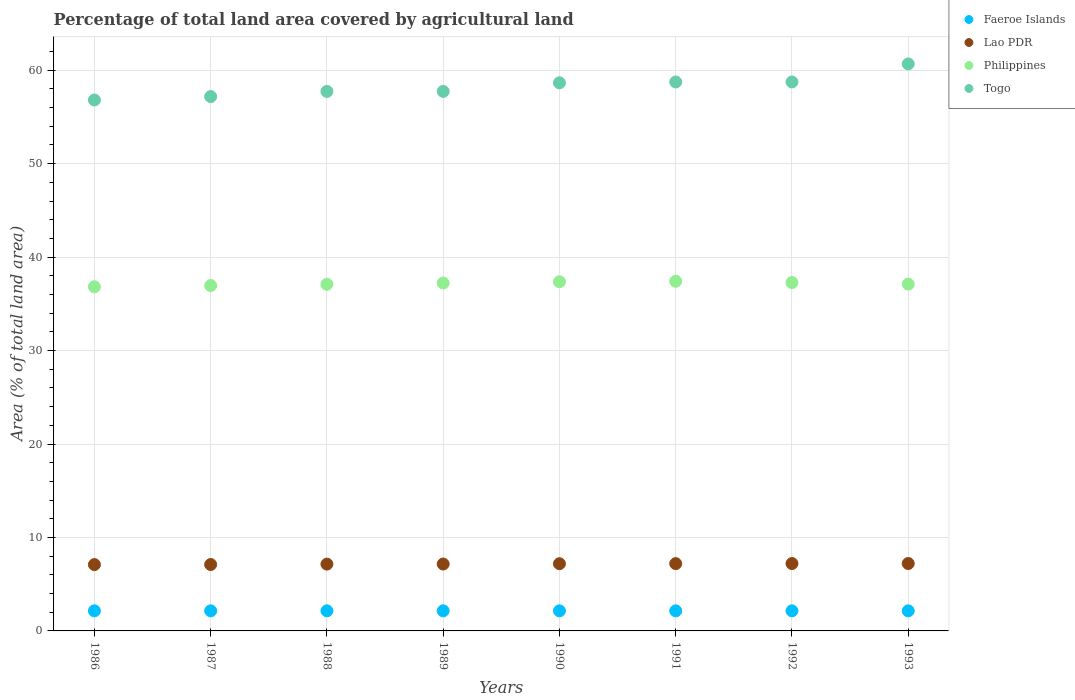How many different coloured dotlines are there?
Offer a very short reply. 4. What is the percentage of agricultural land in Faeroe Islands in 1986?
Provide a succinct answer. 2.15. Across all years, what is the maximum percentage of agricultural land in Lao PDR?
Your answer should be very brief. 7.21. Across all years, what is the minimum percentage of agricultural land in Philippines?
Your answer should be compact. 36.82. In which year was the percentage of agricultural land in Lao PDR maximum?
Keep it short and to the point. 1993. In which year was the percentage of agricultural land in Lao PDR minimum?
Your answer should be compact. 1986. What is the total percentage of agricultural land in Togo in the graph?
Provide a short and direct response. 466.26. What is the difference between the percentage of agricultural land in Philippines in 1987 and that in 1992?
Give a very brief answer. -0.32. What is the difference between the percentage of agricultural land in Togo in 1991 and the percentage of agricultural land in Lao PDR in 1988?
Provide a succinct answer. 51.59. What is the average percentage of agricultural land in Faeroe Islands per year?
Keep it short and to the point. 2.15. In the year 1993, what is the difference between the percentage of agricultural land in Faeroe Islands and percentage of agricultural land in Lao PDR?
Provide a succinct answer. -5.07. In how many years, is the percentage of agricultural land in Togo greater than 34 %?
Offer a terse response. 8. What is the ratio of the percentage of agricultural land in Lao PDR in 1987 to that in 1988?
Make the answer very short. 0.99. What is the difference between the highest and the second highest percentage of agricultural land in Philippines?
Offer a very short reply. 0.06. What is the difference between the highest and the lowest percentage of agricultural land in Togo?
Offer a very short reply. 3.86. Is the sum of the percentage of agricultural land in Philippines in 1986 and 1993 greater than the maximum percentage of agricultural land in Lao PDR across all years?
Your response must be concise. Yes. Is it the case that in every year, the sum of the percentage of agricultural land in Faeroe Islands and percentage of agricultural land in Lao PDR  is greater than the percentage of agricultural land in Togo?
Offer a terse response. No. Does the percentage of agricultural land in Togo monotonically increase over the years?
Your answer should be very brief. No. Is the percentage of agricultural land in Philippines strictly greater than the percentage of agricultural land in Togo over the years?
Provide a short and direct response. No. Is the percentage of agricultural land in Philippines strictly less than the percentage of agricultural land in Togo over the years?
Your answer should be compact. Yes. What is the difference between two consecutive major ticks on the Y-axis?
Offer a terse response. 10. Does the graph contain grids?
Give a very brief answer. Yes. How many legend labels are there?
Offer a terse response. 4. How are the legend labels stacked?
Your answer should be compact. Vertical. What is the title of the graph?
Offer a terse response. Percentage of total land area covered by agricultural land. Does "Brunei Darussalam" appear as one of the legend labels in the graph?
Keep it short and to the point. No. What is the label or title of the Y-axis?
Give a very brief answer. Area (% of total land area). What is the Area (% of total land area) in Faeroe Islands in 1986?
Keep it short and to the point. 2.15. What is the Area (% of total land area) of Lao PDR in 1986?
Your answer should be very brief. 7.1. What is the Area (% of total land area) of Philippines in 1986?
Keep it short and to the point. 36.82. What is the Area (% of total land area) in Togo in 1986?
Your answer should be very brief. 56.81. What is the Area (% of total land area) in Faeroe Islands in 1987?
Ensure brevity in your answer.  2.15. What is the Area (% of total land area) of Lao PDR in 1987?
Offer a terse response. 7.11. What is the Area (% of total land area) of Philippines in 1987?
Make the answer very short. 36.96. What is the Area (% of total land area) in Togo in 1987?
Make the answer very short. 57.18. What is the Area (% of total land area) of Faeroe Islands in 1988?
Your response must be concise. 2.15. What is the Area (% of total land area) of Lao PDR in 1988?
Offer a very short reply. 7.15. What is the Area (% of total land area) in Philippines in 1988?
Provide a succinct answer. 37.09. What is the Area (% of total land area) of Togo in 1988?
Your answer should be very brief. 57.73. What is the Area (% of total land area) of Faeroe Islands in 1989?
Keep it short and to the point. 2.15. What is the Area (% of total land area) in Lao PDR in 1989?
Give a very brief answer. 7.16. What is the Area (% of total land area) of Philippines in 1989?
Offer a very short reply. 37.23. What is the Area (% of total land area) in Togo in 1989?
Make the answer very short. 57.73. What is the Area (% of total land area) in Faeroe Islands in 1990?
Your answer should be very brief. 2.15. What is the Area (% of total land area) in Lao PDR in 1990?
Offer a very short reply. 7.19. What is the Area (% of total land area) in Philippines in 1990?
Provide a short and direct response. 37.36. What is the Area (% of total land area) of Togo in 1990?
Offer a terse response. 58.65. What is the Area (% of total land area) in Faeroe Islands in 1991?
Give a very brief answer. 2.15. What is the Area (% of total land area) of Lao PDR in 1991?
Your answer should be very brief. 7.2. What is the Area (% of total land area) in Philippines in 1991?
Give a very brief answer. 37.42. What is the Area (% of total land area) of Togo in 1991?
Offer a very short reply. 58.74. What is the Area (% of total land area) of Faeroe Islands in 1992?
Offer a terse response. 2.15. What is the Area (% of total land area) of Lao PDR in 1992?
Give a very brief answer. 7.21. What is the Area (% of total land area) in Philippines in 1992?
Your response must be concise. 37.28. What is the Area (% of total land area) in Togo in 1992?
Offer a very short reply. 58.74. What is the Area (% of total land area) of Faeroe Islands in 1993?
Offer a very short reply. 2.15. What is the Area (% of total land area) of Lao PDR in 1993?
Make the answer very short. 7.21. What is the Area (% of total land area) of Philippines in 1993?
Offer a terse response. 37.11. What is the Area (% of total land area) of Togo in 1993?
Offer a very short reply. 60.67. Across all years, what is the maximum Area (% of total land area) in Faeroe Islands?
Give a very brief answer. 2.15. Across all years, what is the maximum Area (% of total land area) of Lao PDR?
Offer a terse response. 7.21. Across all years, what is the maximum Area (% of total land area) in Philippines?
Make the answer very short. 37.42. Across all years, what is the maximum Area (% of total land area) of Togo?
Your response must be concise. 60.67. Across all years, what is the minimum Area (% of total land area) in Faeroe Islands?
Offer a terse response. 2.15. Across all years, what is the minimum Area (% of total land area) of Lao PDR?
Offer a very short reply. 7.1. Across all years, what is the minimum Area (% of total land area) of Philippines?
Offer a terse response. 36.82. Across all years, what is the minimum Area (% of total land area) of Togo?
Provide a succinct answer. 56.81. What is the total Area (% of total land area) of Faeroe Islands in the graph?
Provide a succinct answer. 17.19. What is the total Area (% of total land area) of Lao PDR in the graph?
Offer a terse response. 57.33. What is the total Area (% of total land area) of Philippines in the graph?
Provide a short and direct response. 297.27. What is the total Area (% of total land area) in Togo in the graph?
Give a very brief answer. 466.26. What is the difference between the Area (% of total land area) in Lao PDR in 1986 and that in 1987?
Provide a succinct answer. -0.01. What is the difference between the Area (% of total land area) of Philippines in 1986 and that in 1987?
Offer a very short reply. -0.13. What is the difference between the Area (% of total land area) of Togo in 1986 and that in 1987?
Provide a succinct answer. -0.37. What is the difference between the Area (% of total land area) of Lao PDR in 1986 and that in 1988?
Provide a short and direct response. -0.05. What is the difference between the Area (% of total land area) of Philippines in 1986 and that in 1988?
Your response must be concise. -0.27. What is the difference between the Area (% of total land area) in Togo in 1986 and that in 1988?
Offer a terse response. -0.92. What is the difference between the Area (% of total land area) of Lao PDR in 1986 and that in 1989?
Your answer should be very brief. -0.06. What is the difference between the Area (% of total land area) in Philippines in 1986 and that in 1989?
Keep it short and to the point. -0.4. What is the difference between the Area (% of total land area) of Togo in 1986 and that in 1989?
Offer a terse response. -0.92. What is the difference between the Area (% of total land area) in Lao PDR in 1986 and that in 1990?
Your response must be concise. -0.1. What is the difference between the Area (% of total land area) in Philippines in 1986 and that in 1990?
Keep it short and to the point. -0.54. What is the difference between the Area (% of total land area) of Togo in 1986 and that in 1990?
Keep it short and to the point. -1.84. What is the difference between the Area (% of total land area) in Faeroe Islands in 1986 and that in 1991?
Make the answer very short. 0. What is the difference between the Area (% of total land area) of Lao PDR in 1986 and that in 1991?
Ensure brevity in your answer.  -0.1. What is the difference between the Area (% of total land area) of Philippines in 1986 and that in 1991?
Offer a terse response. -0.59. What is the difference between the Area (% of total land area) in Togo in 1986 and that in 1991?
Offer a very short reply. -1.93. What is the difference between the Area (% of total land area) in Lao PDR in 1986 and that in 1992?
Provide a short and direct response. -0.11. What is the difference between the Area (% of total land area) in Philippines in 1986 and that in 1992?
Give a very brief answer. -0.45. What is the difference between the Area (% of total land area) of Togo in 1986 and that in 1992?
Offer a very short reply. -1.93. What is the difference between the Area (% of total land area) of Lao PDR in 1986 and that in 1993?
Your answer should be compact. -0.12. What is the difference between the Area (% of total land area) of Philippines in 1986 and that in 1993?
Your response must be concise. -0.29. What is the difference between the Area (% of total land area) of Togo in 1986 and that in 1993?
Offer a terse response. -3.86. What is the difference between the Area (% of total land area) in Lao PDR in 1987 and that in 1988?
Your response must be concise. -0.04. What is the difference between the Area (% of total land area) in Philippines in 1987 and that in 1988?
Provide a succinct answer. -0.13. What is the difference between the Area (% of total land area) of Togo in 1987 and that in 1988?
Provide a short and direct response. -0.55. What is the difference between the Area (% of total land area) in Faeroe Islands in 1987 and that in 1989?
Provide a short and direct response. 0. What is the difference between the Area (% of total land area) of Lao PDR in 1987 and that in 1989?
Provide a short and direct response. -0.05. What is the difference between the Area (% of total land area) of Philippines in 1987 and that in 1989?
Your answer should be very brief. -0.27. What is the difference between the Area (% of total land area) of Togo in 1987 and that in 1989?
Give a very brief answer. -0.55. What is the difference between the Area (% of total land area) in Faeroe Islands in 1987 and that in 1990?
Provide a succinct answer. 0. What is the difference between the Area (% of total land area) in Lao PDR in 1987 and that in 1990?
Your answer should be very brief. -0.09. What is the difference between the Area (% of total land area) of Philippines in 1987 and that in 1990?
Your answer should be compact. -0.4. What is the difference between the Area (% of total land area) in Togo in 1987 and that in 1990?
Your response must be concise. -1.47. What is the difference between the Area (% of total land area) in Lao PDR in 1987 and that in 1991?
Make the answer very short. -0.1. What is the difference between the Area (% of total land area) of Philippines in 1987 and that in 1991?
Make the answer very short. -0.46. What is the difference between the Area (% of total land area) of Togo in 1987 and that in 1991?
Make the answer very short. -1.56. What is the difference between the Area (% of total land area) of Lao PDR in 1987 and that in 1992?
Provide a short and direct response. -0.1. What is the difference between the Area (% of total land area) in Philippines in 1987 and that in 1992?
Your response must be concise. -0.32. What is the difference between the Area (% of total land area) of Togo in 1987 and that in 1992?
Provide a short and direct response. -1.56. What is the difference between the Area (% of total land area) of Faeroe Islands in 1987 and that in 1993?
Ensure brevity in your answer.  0. What is the difference between the Area (% of total land area) of Lao PDR in 1987 and that in 1993?
Provide a short and direct response. -0.11. What is the difference between the Area (% of total land area) in Philippines in 1987 and that in 1993?
Offer a terse response. -0.15. What is the difference between the Area (% of total land area) in Togo in 1987 and that in 1993?
Give a very brief answer. -3.49. What is the difference between the Area (% of total land area) of Faeroe Islands in 1988 and that in 1989?
Give a very brief answer. 0. What is the difference between the Area (% of total land area) of Lao PDR in 1988 and that in 1989?
Keep it short and to the point. -0.01. What is the difference between the Area (% of total land area) of Philippines in 1988 and that in 1989?
Make the answer very short. -0.13. What is the difference between the Area (% of total land area) in Togo in 1988 and that in 1989?
Offer a terse response. 0. What is the difference between the Area (% of total land area) of Faeroe Islands in 1988 and that in 1990?
Your answer should be very brief. 0. What is the difference between the Area (% of total land area) in Lao PDR in 1988 and that in 1990?
Offer a very short reply. -0.04. What is the difference between the Area (% of total land area) in Philippines in 1988 and that in 1990?
Give a very brief answer. -0.27. What is the difference between the Area (% of total land area) of Togo in 1988 and that in 1990?
Provide a succinct answer. -0.92. What is the difference between the Area (% of total land area) of Faeroe Islands in 1988 and that in 1991?
Provide a short and direct response. 0. What is the difference between the Area (% of total land area) of Lao PDR in 1988 and that in 1991?
Offer a terse response. -0.05. What is the difference between the Area (% of total land area) of Philippines in 1988 and that in 1991?
Make the answer very short. -0.33. What is the difference between the Area (% of total land area) of Togo in 1988 and that in 1991?
Keep it short and to the point. -1.01. What is the difference between the Area (% of total land area) of Faeroe Islands in 1988 and that in 1992?
Ensure brevity in your answer.  0. What is the difference between the Area (% of total land area) in Lao PDR in 1988 and that in 1992?
Offer a very short reply. -0.06. What is the difference between the Area (% of total land area) in Philippines in 1988 and that in 1992?
Offer a terse response. -0.18. What is the difference between the Area (% of total land area) in Togo in 1988 and that in 1992?
Offer a terse response. -1.01. What is the difference between the Area (% of total land area) of Lao PDR in 1988 and that in 1993?
Your response must be concise. -0.07. What is the difference between the Area (% of total land area) of Philippines in 1988 and that in 1993?
Keep it short and to the point. -0.02. What is the difference between the Area (% of total land area) in Togo in 1988 and that in 1993?
Your answer should be very brief. -2.94. What is the difference between the Area (% of total land area) of Lao PDR in 1989 and that in 1990?
Offer a terse response. -0.03. What is the difference between the Area (% of total land area) in Philippines in 1989 and that in 1990?
Your answer should be compact. -0.13. What is the difference between the Area (% of total land area) in Togo in 1989 and that in 1990?
Offer a terse response. -0.92. What is the difference between the Area (% of total land area) in Lao PDR in 1989 and that in 1991?
Ensure brevity in your answer.  -0.04. What is the difference between the Area (% of total land area) in Philippines in 1989 and that in 1991?
Your answer should be very brief. -0.19. What is the difference between the Area (% of total land area) in Togo in 1989 and that in 1991?
Provide a succinct answer. -1.01. What is the difference between the Area (% of total land area) in Lao PDR in 1989 and that in 1992?
Your response must be concise. -0.05. What is the difference between the Area (% of total land area) in Philippines in 1989 and that in 1992?
Offer a very short reply. -0.05. What is the difference between the Area (% of total land area) of Togo in 1989 and that in 1992?
Keep it short and to the point. -1.01. What is the difference between the Area (% of total land area) of Lao PDR in 1989 and that in 1993?
Make the answer very short. -0.06. What is the difference between the Area (% of total land area) of Philippines in 1989 and that in 1993?
Ensure brevity in your answer.  0.12. What is the difference between the Area (% of total land area) in Togo in 1989 and that in 1993?
Make the answer very short. -2.94. What is the difference between the Area (% of total land area) of Faeroe Islands in 1990 and that in 1991?
Keep it short and to the point. 0. What is the difference between the Area (% of total land area) of Lao PDR in 1990 and that in 1991?
Ensure brevity in your answer.  -0.01. What is the difference between the Area (% of total land area) of Philippines in 1990 and that in 1991?
Your answer should be compact. -0.06. What is the difference between the Area (% of total land area) in Togo in 1990 and that in 1991?
Your answer should be compact. -0.09. What is the difference between the Area (% of total land area) in Lao PDR in 1990 and that in 1992?
Your response must be concise. -0.02. What is the difference between the Area (% of total land area) in Philippines in 1990 and that in 1992?
Make the answer very short. 0.08. What is the difference between the Area (% of total land area) in Togo in 1990 and that in 1992?
Provide a short and direct response. -0.09. What is the difference between the Area (% of total land area) of Lao PDR in 1990 and that in 1993?
Provide a short and direct response. -0.02. What is the difference between the Area (% of total land area) in Philippines in 1990 and that in 1993?
Your answer should be compact. 0.25. What is the difference between the Area (% of total land area) of Togo in 1990 and that in 1993?
Make the answer very short. -2.02. What is the difference between the Area (% of total land area) of Lao PDR in 1991 and that in 1992?
Provide a short and direct response. -0.01. What is the difference between the Area (% of total land area) of Philippines in 1991 and that in 1992?
Your response must be concise. 0.14. What is the difference between the Area (% of total land area) in Faeroe Islands in 1991 and that in 1993?
Make the answer very short. 0. What is the difference between the Area (% of total land area) in Lao PDR in 1991 and that in 1993?
Keep it short and to the point. -0.01. What is the difference between the Area (% of total land area) in Philippines in 1991 and that in 1993?
Offer a very short reply. 0.31. What is the difference between the Area (% of total land area) of Togo in 1991 and that in 1993?
Your answer should be very brief. -1.93. What is the difference between the Area (% of total land area) of Faeroe Islands in 1992 and that in 1993?
Provide a short and direct response. 0. What is the difference between the Area (% of total land area) in Lao PDR in 1992 and that in 1993?
Give a very brief answer. -0. What is the difference between the Area (% of total land area) in Philippines in 1992 and that in 1993?
Your response must be concise. 0.17. What is the difference between the Area (% of total land area) in Togo in 1992 and that in 1993?
Keep it short and to the point. -1.93. What is the difference between the Area (% of total land area) in Faeroe Islands in 1986 and the Area (% of total land area) in Lao PDR in 1987?
Give a very brief answer. -4.96. What is the difference between the Area (% of total land area) in Faeroe Islands in 1986 and the Area (% of total land area) in Philippines in 1987?
Provide a succinct answer. -34.81. What is the difference between the Area (% of total land area) of Faeroe Islands in 1986 and the Area (% of total land area) of Togo in 1987?
Provide a succinct answer. -55.03. What is the difference between the Area (% of total land area) of Lao PDR in 1986 and the Area (% of total land area) of Philippines in 1987?
Provide a succinct answer. -29.86. What is the difference between the Area (% of total land area) in Lao PDR in 1986 and the Area (% of total land area) in Togo in 1987?
Provide a short and direct response. -50.08. What is the difference between the Area (% of total land area) in Philippines in 1986 and the Area (% of total land area) in Togo in 1987?
Give a very brief answer. -20.36. What is the difference between the Area (% of total land area) in Faeroe Islands in 1986 and the Area (% of total land area) in Philippines in 1988?
Provide a short and direct response. -34.94. What is the difference between the Area (% of total land area) in Faeroe Islands in 1986 and the Area (% of total land area) in Togo in 1988?
Your answer should be compact. -55.58. What is the difference between the Area (% of total land area) of Lao PDR in 1986 and the Area (% of total land area) of Philippines in 1988?
Keep it short and to the point. -30. What is the difference between the Area (% of total land area) in Lao PDR in 1986 and the Area (% of total land area) in Togo in 1988?
Ensure brevity in your answer.  -50.63. What is the difference between the Area (% of total land area) of Philippines in 1986 and the Area (% of total land area) of Togo in 1988?
Your answer should be very brief. -20.91. What is the difference between the Area (% of total land area) in Faeroe Islands in 1986 and the Area (% of total land area) in Lao PDR in 1989?
Offer a very short reply. -5.01. What is the difference between the Area (% of total land area) of Faeroe Islands in 1986 and the Area (% of total land area) of Philippines in 1989?
Ensure brevity in your answer.  -35.08. What is the difference between the Area (% of total land area) in Faeroe Islands in 1986 and the Area (% of total land area) in Togo in 1989?
Give a very brief answer. -55.58. What is the difference between the Area (% of total land area) of Lao PDR in 1986 and the Area (% of total land area) of Philippines in 1989?
Keep it short and to the point. -30.13. What is the difference between the Area (% of total land area) in Lao PDR in 1986 and the Area (% of total land area) in Togo in 1989?
Keep it short and to the point. -50.63. What is the difference between the Area (% of total land area) of Philippines in 1986 and the Area (% of total land area) of Togo in 1989?
Ensure brevity in your answer.  -20.91. What is the difference between the Area (% of total land area) in Faeroe Islands in 1986 and the Area (% of total land area) in Lao PDR in 1990?
Your response must be concise. -5.04. What is the difference between the Area (% of total land area) in Faeroe Islands in 1986 and the Area (% of total land area) in Philippines in 1990?
Your response must be concise. -35.21. What is the difference between the Area (% of total land area) in Faeroe Islands in 1986 and the Area (% of total land area) in Togo in 1990?
Your answer should be very brief. -56.5. What is the difference between the Area (% of total land area) of Lao PDR in 1986 and the Area (% of total land area) of Philippines in 1990?
Offer a very short reply. -30.26. What is the difference between the Area (% of total land area) in Lao PDR in 1986 and the Area (% of total land area) in Togo in 1990?
Your answer should be very brief. -51.55. What is the difference between the Area (% of total land area) of Philippines in 1986 and the Area (% of total land area) of Togo in 1990?
Your answer should be very brief. -21.83. What is the difference between the Area (% of total land area) of Faeroe Islands in 1986 and the Area (% of total land area) of Lao PDR in 1991?
Give a very brief answer. -5.05. What is the difference between the Area (% of total land area) in Faeroe Islands in 1986 and the Area (% of total land area) in Philippines in 1991?
Offer a terse response. -35.27. What is the difference between the Area (% of total land area) in Faeroe Islands in 1986 and the Area (% of total land area) in Togo in 1991?
Make the answer very short. -56.59. What is the difference between the Area (% of total land area) of Lao PDR in 1986 and the Area (% of total land area) of Philippines in 1991?
Ensure brevity in your answer.  -30.32. What is the difference between the Area (% of total land area) in Lao PDR in 1986 and the Area (% of total land area) in Togo in 1991?
Provide a succinct answer. -51.65. What is the difference between the Area (% of total land area) in Philippines in 1986 and the Area (% of total land area) in Togo in 1991?
Provide a succinct answer. -21.92. What is the difference between the Area (% of total land area) of Faeroe Islands in 1986 and the Area (% of total land area) of Lao PDR in 1992?
Keep it short and to the point. -5.06. What is the difference between the Area (% of total land area) in Faeroe Islands in 1986 and the Area (% of total land area) in Philippines in 1992?
Your answer should be very brief. -35.13. What is the difference between the Area (% of total land area) of Faeroe Islands in 1986 and the Area (% of total land area) of Togo in 1992?
Your answer should be very brief. -56.59. What is the difference between the Area (% of total land area) in Lao PDR in 1986 and the Area (% of total land area) in Philippines in 1992?
Ensure brevity in your answer.  -30.18. What is the difference between the Area (% of total land area) of Lao PDR in 1986 and the Area (% of total land area) of Togo in 1992?
Provide a succinct answer. -51.65. What is the difference between the Area (% of total land area) of Philippines in 1986 and the Area (% of total land area) of Togo in 1992?
Your response must be concise. -21.92. What is the difference between the Area (% of total land area) of Faeroe Islands in 1986 and the Area (% of total land area) of Lao PDR in 1993?
Your response must be concise. -5.07. What is the difference between the Area (% of total land area) of Faeroe Islands in 1986 and the Area (% of total land area) of Philippines in 1993?
Offer a very short reply. -34.96. What is the difference between the Area (% of total land area) in Faeroe Islands in 1986 and the Area (% of total land area) in Togo in 1993?
Provide a succinct answer. -58.52. What is the difference between the Area (% of total land area) of Lao PDR in 1986 and the Area (% of total land area) of Philippines in 1993?
Provide a short and direct response. -30.01. What is the difference between the Area (% of total land area) of Lao PDR in 1986 and the Area (% of total land area) of Togo in 1993?
Offer a very short reply. -53.58. What is the difference between the Area (% of total land area) of Philippines in 1986 and the Area (% of total land area) of Togo in 1993?
Provide a succinct answer. -23.85. What is the difference between the Area (% of total land area) of Faeroe Islands in 1987 and the Area (% of total land area) of Lao PDR in 1988?
Ensure brevity in your answer.  -5. What is the difference between the Area (% of total land area) of Faeroe Islands in 1987 and the Area (% of total land area) of Philippines in 1988?
Offer a very short reply. -34.94. What is the difference between the Area (% of total land area) in Faeroe Islands in 1987 and the Area (% of total land area) in Togo in 1988?
Ensure brevity in your answer.  -55.58. What is the difference between the Area (% of total land area) in Lao PDR in 1987 and the Area (% of total land area) in Philippines in 1988?
Offer a terse response. -29.99. What is the difference between the Area (% of total land area) in Lao PDR in 1987 and the Area (% of total land area) in Togo in 1988?
Give a very brief answer. -50.63. What is the difference between the Area (% of total land area) of Philippines in 1987 and the Area (% of total land area) of Togo in 1988?
Ensure brevity in your answer.  -20.77. What is the difference between the Area (% of total land area) in Faeroe Islands in 1987 and the Area (% of total land area) in Lao PDR in 1989?
Offer a very short reply. -5.01. What is the difference between the Area (% of total land area) in Faeroe Islands in 1987 and the Area (% of total land area) in Philippines in 1989?
Your response must be concise. -35.08. What is the difference between the Area (% of total land area) in Faeroe Islands in 1987 and the Area (% of total land area) in Togo in 1989?
Ensure brevity in your answer.  -55.58. What is the difference between the Area (% of total land area) of Lao PDR in 1987 and the Area (% of total land area) of Philippines in 1989?
Provide a short and direct response. -30.12. What is the difference between the Area (% of total land area) in Lao PDR in 1987 and the Area (% of total land area) in Togo in 1989?
Your response must be concise. -50.63. What is the difference between the Area (% of total land area) of Philippines in 1987 and the Area (% of total land area) of Togo in 1989?
Offer a terse response. -20.77. What is the difference between the Area (% of total land area) of Faeroe Islands in 1987 and the Area (% of total land area) of Lao PDR in 1990?
Provide a short and direct response. -5.04. What is the difference between the Area (% of total land area) in Faeroe Islands in 1987 and the Area (% of total land area) in Philippines in 1990?
Keep it short and to the point. -35.21. What is the difference between the Area (% of total land area) of Faeroe Islands in 1987 and the Area (% of total land area) of Togo in 1990?
Your answer should be compact. -56.5. What is the difference between the Area (% of total land area) of Lao PDR in 1987 and the Area (% of total land area) of Philippines in 1990?
Provide a short and direct response. -30.26. What is the difference between the Area (% of total land area) of Lao PDR in 1987 and the Area (% of total land area) of Togo in 1990?
Make the answer very short. -51.54. What is the difference between the Area (% of total land area) in Philippines in 1987 and the Area (% of total land area) in Togo in 1990?
Your response must be concise. -21.69. What is the difference between the Area (% of total land area) in Faeroe Islands in 1987 and the Area (% of total land area) in Lao PDR in 1991?
Your answer should be very brief. -5.05. What is the difference between the Area (% of total land area) in Faeroe Islands in 1987 and the Area (% of total land area) in Philippines in 1991?
Provide a short and direct response. -35.27. What is the difference between the Area (% of total land area) in Faeroe Islands in 1987 and the Area (% of total land area) in Togo in 1991?
Your answer should be compact. -56.59. What is the difference between the Area (% of total land area) in Lao PDR in 1987 and the Area (% of total land area) in Philippines in 1991?
Make the answer very short. -30.31. What is the difference between the Area (% of total land area) in Lao PDR in 1987 and the Area (% of total land area) in Togo in 1991?
Give a very brief answer. -51.64. What is the difference between the Area (% of total land area) of Philippines in 1987 and the Area (% of total land area) of Togo in 1991?
Your answer should be compact. -21.78. What is the difference between the Area (% of total land area) in Faeroe Islands in 1987 and the Area (% of total land area) in Lao PDR in 1992?
Your response must be concise. -5.06. What is the difference between the Area (% of total land area) of Faeroe Islands in 1987 and the Area (% of total land area) of Philippines in 1992?
Your answer should be compact. -35.13. What is the difference between the Area (% of total land area) of Faeroe Islands in 1987 and the Area (% of total land area) of Togo in 1992?
Offer a terse response. -56.59. What is the difference between the Area (% of total land area) in Lao PDR in 1987 and the Area (% of total land area) in Philippines in 1992?
Your answer should be very brief. -30.17. What is the difference between the Area (% of total land area) in Lao PDR in 1987 and the Area (% of total land area) in Togo in 1992?
Offer a very short reply. -51.64. What is the difference between the Area (% of total land area) in Philippines in 1987 and the Area (% of total land area) in Togo in 1992?
Keep it short and to the point. -21.78. What is the difference between the Area (% of total land area) of Faeroe Islands in 1987 and the Area (% of total land area) of Lao PDR in 1993?
Provide a short and direct response. -5.07. What is the difference between the Area (% of total land area) in Faeroe Islands in 1987 and the Area (% of total land area) in Philippines in 1993?
Your answer should be compact. -34.96. What is the difference between the Area (% of total land area) of Faeroe Islands in 1987 and the Area (% of total land area) of Togo in 1993?
Make the answer very short. -58.52. What is the difference between the Area (% of total land area) in Lao PDR in 1987 and the Area (% of total land area) in Philippines in 1993?
Provide a short and direct response. -30. What is the difference between the Area (% of total land area) of Lao PDR in 1987 and the Area (% of total land area) of Togo in 1993?
Keep it short and to the point. -53.57. What is the difference between the Area (% of total land area) of Philippines in 1987 and the Area (% of total land area) of Togo in 1993?
Give a very brief answer. -23.71. What is the difference between the Area (% of total land area) in Faeroe Islands in 1988 and the Area (% of total land area) in Lao PDR in 1989?
Keep it short and to the point. -5.01. What is the difference between the Area (% of total land area) in Faeroe Islands in 1988 and the Area (% of total land area) in Philippines in 1989?
Offer a very short reply. -35.08. What is the difference between the Area (% of total land area) of Faeroe Islands in 1988 and the Area (% of total land area) of Togo in 1989?
Your response must be concise. -55.58. What is the difference between the Area (% of total land area) of Lao PDR in 1988 and the Area (% of total land area) of Philippines in 1989?
Offer a terse response. -30.08. What is the difference between the Area (% of total land area) of Lao PDR in 1988 and the Area (% of total land area) of Togo in 1989?
Offer a very short reply. -50.58. What is the difference between the Area (% of total land area) of Philippines in 1988 and the Area (% of total land area) of Togo in 1989?
Your answer should be compact. -20.64. What is the difference between the Area (% of total land area) of Faeroe Islands in 1988 and the Area (% of total land area) of Lao PDR in 1990?
Keep it short and to the point. -5.04. What is the difference between the Area (% of total land area) of Faeroe Islands in 1988 and the Area (% of total land area) of Philippines in 1990?
Your answer should be very brief. -35.21. What is the difference between the Area (% of total land area) of Faeroe Islands in 1988 and the Area (% of total land area) of Togo in 1990?
Keep it short and to the point. -56.5. What is the difference between the Area (% of total land area) in Lao PDR in 1988 and the Area (% of total land area) in Philippines in 1990?
Provide a succinct answer. -30.21. What is the difference between the Area (% of total land area) in Lao PDR in 1988 and the Area (% of total land area) in Togo in 1990?
Ensure brevity in your answer.  -51.5. What is the difference between the Area (% of total land area) in Philippines in 1988 and the Area (% of total land area) in Togo in 1990?
Provide a short and direct response. -21.56. What is the difference between the Area (% of total land area) in Faeroe Islands in 1988 and the Area (% of total land area) in Lao PDR in 1991?
Keep it short and to the point. -5.05. What is the difference between the Area (% of total land area) in Faeroe Islands in 1988 and the Area (% of total land area) in Philippines in 1991?
Your answer should be compact. -35.27. What is the difference between the Area (% of total land area) in Faeroe Islands in 1988 and the Area (% of total land area) in Togo in 1991?
Make the answer very short. -56.59. What is the difference between the Area (% of total land area) in Lao PDR in 1988 and the Area (% of total land area) in Philippines in 1991?
Your answer should be compact. -30.27. What is the difference between the Area (% of total land area) of Lao PDR in 1988 and the Area (% of total land area) of Togo in 1991?
Keep it short and to the point. -51.59. What is the difference between the Area (% of total land area) in Philippines in 1988 and the Area (% of total land area) in Togo in 1991?
Your response must be concise. -21.65. What is the difference between the Area (% of total land area) in Faeroe Islands in 1988 and the Area (% of total land area) in Lao PDR in 1992?
Ensure brevity in your answer.  -5.06. What is the difference between the Area (% of total land area) of Faeroe Islands in 1988 and the Area (% of total land area) of Philippines in 1992?
Give a very brief answer. -35.13. What is the difference between the Area (% of total land area) in Faeroe Islands in 1988 and the Area (% of total land area) in Togo in 1992?
Provide a succinct answer. -56.59. What is the difference between the Area (% of total land area) of Lao PDR in 1988 and the Area (% of total land area) of Philippines in 1992?
Make the answer very short. -30.13. What is the difference between the Area (% of total land area) in Lao PDR in 1988 and the Area (% of total land area) in Togo in 1992?
Provide a succinct answer. -51.59. What is the difference between the Area (% of total land area) of Philippines in 1988 and the Area (% of total land area) of Togo in 1992?
Provide a succinct answer. -21.65. What is the difference between the Area (% of total land area) of Faeroe Islands in 1988 and the Area (% of total land area) of Lao PDR in 1993?
Give a very brief answer. -5.07. What is the difference between the Area (% of total land area) in Faeroe Islands in 1988 and the Area (% of total land area) in Philippines in 1993?
Keep it short and to the point. -34.96. What is the difference between the Area (% of total land area) of Faeroe Islands in 1988 and the Area (% of total land area) of Togo in 1993?
Give a very brief answer. -58.52. What is the difference between the Area (% of total land area) of Lao PDR in 1988 and the Area (% of total land area) of Philippines in 1993?
Make the answer very short. -29.96. What is the difference between the Area (% of total land area) in Lao PDR in 1988 and the Area (% of total land area) in Togo in 1993?
Your response must be concise. -53.52. What is the difference between the Area (% of total land area) in Philippines in 1988 and the Area (% of total land area) in Togo in 1993?
Provide a short and direct response. -23.58. What is the difference between the Area (% of total land area) of Faeroe Islands in 1989 and the Area (% of total land area) of Lao PDR in 1990?
Your answer should be compact. -5.04. What is the difference between the Area (% of total land area) in Faeroe Islands in 1989 and the Area (% of total land area) in Philippines in 1990?
Give a very brief answer. -35.21. What is the difference between the Area (% of total land area) of Faeroe Islands in 1989 and the Area (% of total land area) of Togo in 1990?
Your response must be concise. -56.5. What is the difference between the Area (% of total land area) in Lao PDR in 1989 and the Area (% of total land area) in Philippines in 1990?
Provide a succinct answer. -30.2. What is the difference between the Area (% of total land area) of Lao PDR in 1989 and the Area (% of total land area) of Togo in 1990?
Offer a terse response. -51.49. What is the difference between the Area (% of total land area) in Philippines in 1989 and the Area (% of total land area) in Togo in 1990?
Ensure brevity in your answer.  -21.42. What is the difference between the Area (% of total land area) of Faeroe Islands in 1989 and the Area (% of total land area) of Lao PDR in 1991?
Your answer should be very brief. -5.05. What is the difference between the Area (% of total land area) of Faeroe Islands in 1989 and the Area (% of total land area) of Philippines in 1991?
Provide a short and direct response. -35.27. What is the difference between the Area (% of total land area) in Faeroe Islands in 1989 and the Area (% of total land area) in Togo in 1991?
Provide a succinct answer. -56.59. What is the difference between the Area (% of total land area) in Lao PDR in 1989 and the Area (% of total land area) in Philippines in 1991?
Your answer should be compact. -30.26. What is the difference between the Area (% of total land area) in Lao PDR in 1989 and the Area (% of total land area) in Togo in 1991?
Ensure brevity in your answer.  -51.58. What is the difference between the Area (% of total land area) of Philippines in 1989 and the Area (% of total land area) of Togo in 1991?
Offer a very short reply. -21.52. What is the difference between the Area (% of total land area) in Faeroe Islands in 1989 and the Area (% of total land area) in Lao PDR in 1992?
Offer a very short reply. -5.06. What is the difference between the Area (% of total land area) of Faeroe Islands in 1989 and the Area (% of total land area) of Philippines in 1992?
Your response must be concise. -35.13. What is the difference between the Area (% of total land area) in Faeroe Islands in 1989 and the Area (% of total land area) in Togo in 1992?
Your response must be concise. -56.59. What is the difference between the Area (% of total land area) in Lao PDR in 1989 and the Area (% of total land area) in Philippines in 1992?
Provide a short and direct response. -30.12. What is the difference between the Area (% of total land area) of Lao PDR in 1989 and the Area (% of total land area) of Togo in 1992?
Offer a terse response. -51.58. What is the difference between the Area (% of total land area) in Philippines in 1989 and the Area (% of total land area) in Togo in 1992?
Give a very brief answer. -21.52. What is the difference between the Area (% of total land area) in Faeroe Islands in 1989 and the Area (% of total land area) in Lao PDR in 1993?
Offer a terse response. -5.07. What is the difference between the Area (% of total land area) of Faeroe Islands in 1989 and the Area (% of total land area) of Philippines in 1993?
Offer a very short reply. -34.96. What is the difference between the Area (% of total land area) in Faeroe Islands in 1989 and the Area (% of total land area) in Togo in 1993?
Offer a very short reply. -58.52. What is the difference between the Area (% of total land area) in Lao PDR in 1989 and the Area (% of total land area) in Philippines in 1993?
Ensure brevity in your answer.  -29.95. What is the difference between the Area (% of total land area) of Lao PDR in 1989 and the Area (% of total land area) of Togo in 1993?
Provide a short and direct response. -53.52. What is the difference between the Area (% of total land area) of Philippines in 1989 and the Area (% of total land area) of Togo in 1993?
Your answer should be very brief. -23.45. What is the difference between the Area (% of total land area) of Faeroe Islands in 1990 and the Area (% of total land area) of Lao PDR in 1991?
Ensure brevity in your answer.  -5.05. What is the difference between the Area (% of total land area) of Faeroe Islands in 1990 and the Area (% of total land area) of Philippines in 1991?
Offer a terse response. -35.27. What is the difference between the Area (% of total land area) in Faeroe Islands in 1990 and the Area (% of total land area) in Togo in 1991?
Provide a short and direct response. -56.59. What is the difference between the Area (% of total land area) in Lao PDR in 1990 and the Area (% of total land area) in Philippines in 1991?
Your answer should be very brief. -30.23. What is the difference between the Area (% of total land area) of Lao PDR in 1990 and the Area (% of total land area) of Togo in 1991?
Keep it short and to the point. -51.55. What is the difference between the Area (% of total land area) of Philippines in 1990 and the Area (% of total land area) of Togo in 1991?
Your response must be concise. -21.38. What is the difference between the Area (% of total land area) in Faeroe Islands in 1990 and the Area (% of total land area) in Lao PDR in 1992?
Your answer should be compact. -5.06. What is the difference between the Area (% of total land area) of Faeroe Islands in 1990 and the Area (% of total land area) of Philippines in 1992?
Your answer should be compact. -35.13. What is the difference between the Area (% of total land area) in Faeroe Islands in 1990 and the Area (% of total land area) in Togo in 1992?
Your answer should be very brief. -56.59. What is the difference between the Area (% of total land area) in Lao PDR in 1990 and the Area (% of total land area) in Philippines in 1992?
Your response must be concise. -30.09. What is the difference between the Area (% of total land area) of Lao PDR in 1990 and the Area (% of total land area) of Togo in 1992?
Make the answer very short. -51.55. What is the difference between the Area (% of total land area) in Philippines in 1990 and the Area (% of total land area) in Togo in 1992?
Offer a very short reply. -21.38. What is the difference between the Area (% of total land area) in Faeroe Islands in 1990 and the Area (% of total land area) in Lao PDR in 1993?
Make the answer very short. -5.07. What is the difference between the Area (% of total land area) of Faeroe Islands in 1990 and the Area (% of total land area) of Philippines in 1993?
Keep it short and to the point. -34.96. What is the difference between the Area (% of total land area) of Faeroe Islands in 1990 and the Area (% of total land area) of Togo in 1993?
Provide a short and direct response. -58.52. What is the difference between the Area (% of total land area) of Lao PDR in 1990 and the Area (% of total land area) of Philippines in 1993?
Ensure brevity in your answer.  -29.92. What is the difference between the Area (% of total land area) in Lao PDR in 1990 and the Area (% of total land area) in Togo in 1993?
Offer a very short reply. -53.48. What is the difference between the Area (% of total land area) in Philippines in 1990 and the Area (% of total land area) in Togo in 1993?
Offer a terse response. -23.31. What is the difference between the Area (% of total land area) of Faeroe Islands in 1991 and the Area (% of total land area) of Lao PDR in 1992?
Provide a short and direct response. -5.06. What is the difference between the Area (% of total land area) in Faeroe Islands in 1991 and the Area (% of total land area) in Philippines in 1992?
Offer a very short reply. -35.13. What is the difference between the Area (% of total land area) in Faeroe Islands in 1991 and the Area (% of total land area) in Togo in 1992?
Your answer should be very brief. -56.59. What is the difference between the Area (% of total land area) of Lao PDR in 1991 and the Area (% of total land area) of Philippines in 1992?
Ensure brevity in your answer.  -30.08. What is the difference between the Area (% of total land area) in Lao PDR in 1991 and the Area (% of total land area) in Togo in 1992?
Your answer should be very brief. -51.54. What is the difference between the Area (% of total land area) of Philippines in 1991 and the Area (% of total land area) of Togo in 1992?
Give a very brief answer. -21.32. What is the difference between the Area (% of total land area) in Faeroe Islands in 1991 and the Area (% of total land area) in Lao PDR in 1993?
Your answer should be compact. -5.07. What is the difference between the Area (% of total land area) in Faeroe Islands in 1991 and the Area (% of total land area) in Philippines in 1993?
Keep it short and to the point. -34.96. What is the difference between the Area (% of total land area) of Faeroe Islands in 1991 and the Area (% of total land area) of Togo in 1993?
Give a very brief answer. -58.52. What is the difference between the Area (% of total land area) of Lao PDR in 1991 and the Area (% of total land area) of Philippines in 1993?
Your answer should be very brief. -29.91. What is the difference between the Area (% of total land area) of Lao PDR in 1991 and the Area (% of total land area) of Togo in 1993?
Make the answer very short. -53.47. What is the difference between the Area (% of total land area) of Philippines in 1991 and the Area (% of total land area) of Togo in 1993?
Your answer should be compact. -23.25. What is the difference between the Area (% of total land area) in Faeroe Islands in 1992 and the Area (% of total land area) in Lao PDR in 1993?
Your answer should be very brief. -5.07. What is the difference between the Area (% of total land area) of Faeroe Islands in 1992 and the Area (% of total land area) of Philippines in 1993?
Ensure brevity in your answer.  -34.96. What is the difference between the Area (% of total land area) in Faeroe Islands in 1992 and the Area (% of total land area) in Togo in 1993?
Your answer should be very brief. -58.52. What is the difference between the Area (% of total land area) in Lao PDR in 1992 and the Area (% of total land area) in Philippines in 1993?
Ensure brevity in your answer.  -29.9. What is the difference between the Area (% of total land area) of Lao PDR in 1992 and the Area (% of total land area) of Togo in 1993?
Your answer should be very brief. -53.46. What is the difference between the Area (% of total land area) in Philippines in 1992 and the Area (% of total land area) in Togo in 1993?
Keep it short and to the point. -23.4. What is the average Area (% of total land area) in Faeroe Islands per year?
Offer a terse response. 2.15. What is the average Area (% of total land area) in Lao PDR per year?
Your answer should be very brief. 7.17. What is the average Area (% of total land area) of Philippines per year?
Offer a terse response. 37.16. What is the average Area (% of total land area) of Togo per year?
Provide a succinct answer. 58.28. In the year 1986, what is the difference between the Area (% of total land area) in Faeroe Islands and Area (% of total land area) in Lao PDR?
Keep it short and to the point. -4.95. In the year 1986, what is the difference between the Area (% of total land area) in Faeroe Islands and Area (% of total land area) in Philippines?
Keep it short and to the point. -34.68. In the year 1986, what is the difference between the Area (% of total land area) in Faeroe Islands and Area (% of total land area) in Togo?
Your answer should be very brief. -54.66. In the year 1986, what is the difference between the Area (% of total land area) in Lao PDR and Area (% of total land area) in Philippines?
Your answer should be very brief. -29.73. In the year 1986, what is the difference between the Area (% of total land area) in Lao PDR and Area (% of total land area) in Togo?
Offer a very short reply. -49.71. In the year 1986, what is the difference between the Area (% of total land area) of Philippines and Area (% of total land area) of Togo?
Offer a very short reply. -19.99. In the year 1987, what is the difference between the Area (% of total land area) in Faeroe Islands and Area (% of total land area) in Lao PDR?
Your response must be concise. -4.96. In the year 1987, what is the difference between the Area (% of total land area) in Faeroe Islands and Area (% of total land area) in Philippines?
Make the answer very short. -34.81. In the year 1987, what is the difference between the Area (% of total land area) of Faeroe Islands and Area (% of total land area) of Togo?
Offer a terse response. -55.03. In the year 1987, what is the difference between the Area (% of total land area) in Lao PDR and Area (% of total land area) in Philippines?
Your answer should be very brief. -29.85. In the year 1987, what is the difference between the Area (% of total land area) of Lao PDR and Area (% of total land area) of Togo?
Keep it short and to the point. -50.07. In the year 1987, what is the difference between the Area (% of total land area) of Philippines and Area (% of total land area) of Togo?
Provide a succinct answer. -20.22. In the year 1988, what is the difference between the Area (% of total land area) of Faeroe Islands and Area (% of total land area) of Lao PDR?
Provide a short and direct response. -5. In the year 1988, what is the difference between the Area (% of total land area) in Faeroe Islands and Area (% of total land area) in Philippines?
Make the answer very short. -34.94. In the year 1988, what is the difference between the Area (% of total land area) of Faeroe Islands and Area (% of total land area) of Togo?
Provide a short and direct response. -55.58. In the year 1988, what is the difference between the Area (% of total land area) in Lao PDR and Area (% of total land area) in Philippines?
Provide a short and direct response. -29.94. In the year 1988, what is the difference between the Area (% of total land area) in Lao PDR and Area (% of total land area) in Togo?
Your answer should be very brief. -50.58. In the year 1988, what is the difference between the Area (% of total land area) of Philippines and Area (% of total land area) of Togo?
Your answer should be compact. -20.64. In the year 1989, what is the difference between the Area (% of total land area) of Faeroe Islands and Area (% of total land area) of Lao PDR?
Your answer should be compact. -5.01. In the year 1989, what is the difference between the Area (% of total land area) of Faeroe Islands and Area (% of total land area) of Philippines?
Make the answer very short. -35.08. In the year 1989, what is the difference between the Area (% of total land area) in Faeroe Islands and Area (% of total land area) in Togo?
Give a very brief answer. -55.58. In the year 1989, what is the difference between the Area (% of total land area) in Lao PDR and Area (% of total land area) in Philippines?
Offer a terse response. -30.07. In the year 1989, what is the difference between the Area (% of total land area) of Lao PDR and Area (% of total land area) of Togo?
Your response must be concise. -50.57. In the year 1989, what is the difference between the Area (% of total land area) in Philippines and Area (% of total land area) in Togo?
Your answer should be compact. -20.5. In the year 1990, what is the difference between the Area (% of total land area) in Faeroe Islands and Area (% of total land area) in Lao PDR?
Make the answer very short. -5.04. In the year 1990, what is the difference between the Area (% of total land area) in Faeroe Islands and Area (% of total land area) in Philippines?
Give a very brief answer. -35.21. In the year 1990, what is the difference between the Area (% of total land area) in Faeroe Islands and Area (% of total land area) in Togo?
Your answer should be very brief. -56.5. In the year 1990, what is the difference between the Area (% of total land area) of Lao PDR and Area (% of total land area) of Philippines?
Make the answer very short. -30.17. In the year 1990, what is the difference between the Area (% of total land area) in Lao PDR and Area (% of total land area) in Togo?
Your answer should be compact. -51.46. In the year 1990, what is the difference between the Area (% of total land area) in Philippines and Area (% of total land area) in Togo?
Make the answer very short. -21.29. In the year 1991, what is the difference between the Area (% of total land area) in Faeroe Islands and Area (% of total land area) in Lao PDR?
Provide a succinct answer. -5.05. In the year 1991, what is the difference between the Area (% of total land area) in Faeroe Islands and Area (% of total land area) in Philippines?
Your answer should be compact. -35.27. In the year 1991, what is the difference between the Area (% of total land area) in Faeroe Islands and Area (% of total land area) in Togo?
Your answer should be compact. -56.59. In the year 1991, what is the difference between the Area (% of total land area) of Lao PDR and Area (% of total land area) of Philippines?
Offer a terse response. -30.22. In the year 1991, what is the difference between the Area (% of total land area) in Lao PDR and Area (% of total land area) in Togo?
Your answer should be very brief. -51.54. In the year 1991, what is the difference between the Area (% of total land area) in Philippines and Area (% of total land area) in Togo?
Make the answer very short. -21.32. In the year 1992, what is the difference between the Area (% of total land area) of Faeroe Islands and Area (% of total land area) of Lao PDR?
Your answer should be compact. -5.06. In the year 1992, what is the difference between the Area (% of total land area) in Faeroe Islands and Area (% of total land area) in Philippines?
Your answer should be compact. -35.13. In the year 1992, what is the difference between the Area (% of total land area) in Faeroe Islands and Area (% of total land area) in Togo?
Make the answer very short. -56.59. In the year 1992, what is the difference between the Area (% of total land area) of Lao PDR and Area (% of total land area) of Philippines?
Keep it short and to the point. -30.07. In the year 1992, what is the difference between the Area (% of total land area) of Lao PDR and Area (% of total land area) of Togo?
Ensure brevity in your answer.  -51.53. In the year 1992, what is the difference between the Area (% of total land area) in Philippines and Area (% of total land area) in Togo?
Offer a very short reply. -21.46. In the year 1993, what is the difference between the Area (% of total land area) of Faeroe Islands and Area (% of total land area) of Lao PDR?
Ensure brevity in your answer.  -5.07. In the year 1993, what is the difference between the Area (% of total land area) in Faeroe Islands and Area (% of total land area) in Philippines?
Provide a short and direct response. -34.96. In the year 1993, what is the difference between the Area (% of total land area) of Faeroe Islands and Area (% of total land area) of Togo?
Offer a terse response. -58.52. In the year 1993, what is the difference between the Area (% of total land area) of Lao PDR and Area (% of total land area) of Philippines?
Your response must be concise. -29.9. In the year 1993, what is the difference between the Area (% of total land area) of Lao PDR and Area (% of total land area) of Togo?
Your answer should be compact. -53.46. In the year 1993, what is the difference between the Area (% of total land area) in Philippines and Area (% of total land area) in Togo?
Make the answer very short. -23.56. What is the ratio of the Area (% of total land area) of Lao PDR in 1986 to that in 1987?
Offer a terse response. 1. What is the ratio of the Area (% of total land area) of Philippines in 1986 to that in 1987?
Offer a terse response. 1. What is the ratio of the Area (% of total land area) in Togo in 1986 to that in 1987?
Your response must be concise. 0.99. What is the ratio of the Area (% of total land area) in Philippines in 1986 to that in 1988?
Ensure brevity in your answer.  0.99. What is the ratio of the Area (% of total land area) of Togo in 1986 to that in 1988?
Make the answer very short. 0.98. What is the ratio of the Area (% of total land area) in Faeroe Islands in 1986 to that in 1989?
Your answer should be compact. 1. What is the ratio of the Area (% of total land area) in Togo in 1986 to that in 1989?
Offer a very short reply. 0.98. What is the ratio of the Area (% of total land area) in Lao PDR in 1986 to that in 1990?
Your response must be concise. 0.99. What is the ratio of the Area (% of total land area) in Philippines in 1986 to that in 1990?
Make the answer very short. 0.99. What is the ratio of the Area (% of total land area) of Togo in 1986 to that in 1990?
Your response must be concise. 0.97. What is the ratio of the Area (% of total land area) in Lao PDR in 1986 to that in 1991?
Your response must be concise. 0.99. What is the ratio of the Area (% of total land area) in Philippines in 1986 to that in 1991?
Give a very brief answer. 0.98. What is the ratio of the Area (% of total land area) in Togo in 1986 to that in 1991?
Give a very brief answer. 0.97. What is the ratio of the Area (% of total land area) of Faeroe Islands in 1986 to that in 1992?
Provide a succinct answer. 1. What is the ratio of the Area (% of total land area) in Lao PDR in 1986 to that in 1992?
Make the answer very short. 0.98. What is the ratio of the Area (% of total land area) in Philippines in 1986 to that in 1992?
Provide a succinct answer. 0.99. What is the ratio of the Area (% of total land area) in Togo in 1986 to that in 1992?
Ensure brevity in your answer.  0.97. What is the ratio of the Area (% of total land area) in Faeroe Islands in 1986 to that in 1993?
Ensure brevity in your answer.  1. What is the ratio of the Area (% of total land area) in Lao PDR in 1986 to that in 1993?
Offer a terse response. 0.98. What is the ratio of the Area (% of total land area) of Philippines in 1986 to that in 1993?
Keep it short and to the point. 0.99. What is the ratio of the Area (% of total land area) in Togo in 1986 to that in 1993?
Ensure brevity in your answer.  0.94. What is the ratio of the Area (% of total land area) in Lao PDR in 1987 to that in 1988?
Provide a short and direct response. 0.99. What is the ratio of the Area (% of total land area) in Togo in 1987 to that in 1988?
Your response must be concise. 0.99. What is the ratio of the Area (% of total land area) in Togo in 1987 to that in 1989?
Give a very brief answer. 0.99. What is the ratio of the Area (% of total land area) in Faeroe Islands in 1987 to that in 1990?
Ensure brevity in your answer.  1. What is the ratio of the Area (% of total land area) in Philippines in 1987 to that in 1990?
Your answer should be compact. 0.99. What is the ratio of the Area (% of total land area) of Togo in 1987 to that in 1990?
Keep it short and to the point. 0.97. What is the ratio of the Area (% of total land area) in Faeroe Islands in 1987 to that in 1991?
Your answer should be compact. 1. What is the ratio of the Area (% of total land area) in Lao PDR in 1987 to that in 1991?
Your answer should be compact. 0.99. What is the ratio of the Area (% of total land area) in Togo in 1987 to that in 1991?
Your answer should be compact. 0.97. What is the ratio of the Area (% of total land area) of Faeroe Islands in 1987 to that in 1992?
Provide a succinct answer. 1. What is the ratio of the Area (% of total land area) of Lao PDR in 1987 to that in 1992?
Provide a short and direct response. 0.99. What is the ratio of the Area (% of total land area) in Togo in 1987 to that in 1992?
Offer a terse response. 0.97. What is the ratio of the Area (% of total land area) of Philippines in 1987 to that in 1993?
Your answer should be compact. 1. What is the ratio of the Area (% of total land area) of Togo in 1987 to that in 1993?
Provide a short and direct response. 0.94. What is the ratio of the Area (% of total land area) in Faeroe Islands in 1988 to that in 1989?
Offer a terse response. 1. What is the ratio of the Area (% of total land area) in Philippines in 1988 to that in 1989?
Make the answer very short. 1. What is the ratio of the Area (% of total land area) in Lao PDR in 1988 to that in 1990?
Give a very brief answer. 0.99. What is the ratio of the Area (% of total land area) in Philippines in 1988 to that in 1990?
Keep it short and to the point. 0.99. What is the ratio of the Area (% of total land area) in Togo in 1988 to that in 1990?
Your answer should be very brief. 0.98. What is the ratio of the Area (% of total land area) in Lao PDR in 1988 to that in 1991?
Provide a short and direct response. 0.99. What is the ratio of the Area (% of total land area) in Philippines in 1988 to that in 1991?
Provide a succinct answer. 0.99. What is the ratio of the Area (% of total land area) of Togo in 1988 to that in 1991?
Offer a very short reply. 0.98. What is the ratio of the Area (% of total land area) of Philippines in 1988 to that in 1992?
Keep it short and to the point. 1. What is the ratio of the Area (% of total land area) in Togo in 1988 to that in 1992?
Give a very brief answer. 0.98. What is the ratio of the Area (% of total land area) in Faeroe Islands in 1988 to that in 1993?
Provide a short and direct response. 1. What is the ratio of the Area (% of total land area) in Lao PDR in 1988 to that in 1993?
Your answer should be compact. 0.99. What is the ratio of the Area (% of total land area) of Philippines in 1988 to that in 1993?
Offer a very short reply. 1. What is the ratio of the Area (% of total land area) of Togo in 1988 to that in 1993?
Give a very brief answer. 0.95. What is the ratio of the Area (% of total land area) in Lao PDR in 1989 to that in 1990?
Your answer should be very brief. 1. What is the ratio of the Area (% of total land area) in Togo in 1989 to that in 1990?
Your answer should be compact. 0.98. What is the ratio of the Area (% of total land area) of Faeroe Islands in 1989 to that in 1991?
Provide a succinct answer. 1. What is the ratio of the Area (% of total land area) of Lao PDR in 1989 to that in 1991?
Your answer should be compact. 0.99. What is the ratio of the Area (% of total land area) of Philippines in 1989 to that in 1991?
Offer a very short reply. 0.99. What is the ratio of the Area (% of total land area) in Togo in 1989 to that in 1991?
Provide a short and direct response. 0.98. What is the ratio of the Area (% of total land area) of Faeroe Islands in 1989 to that in 1992?
Your answer should be very brief. 1. What is the ratio of the Area (% of total land area) of Lao PDR in 1989 to that in 1992?
Your answer should be compact. 0.99. What is the ratio of the Area (% of total land area) of Philippines in 1989 to that in 1992?
Provide a succinct answer. 1. What is the ratio of the Area (% of total land area) in Togo in 1989 to that in 1992?
Your response must be concise. 0.98. What is the ratio of the Area (% of total land area) in Lao PDR in 1989 to that in 1993?
Your response must be concise. 0.99. What is the ratio of the Area (% of total land area) of Philippines in 1989 to that in 1993?
Give a very brief answer. 1. What is the ratio of the Area (% of total land area) of Togo in 1989 to that in 1993?
Ensure brevity in your answer.  0.95. What is the ratio of the Area (% of total land area) in Faeroe Islands in 1990 to that in 1991?
Provide a short and direct response. 1. What is the ratio of the Area (% of total land area) in Togo in 1990 to that in 1991?
Offer a very short reply. 1. What is the ratio of the Area (% of total land area) in Faeroe Islands in 1990 to that in 1992?
Provide a short and direct response. 1. What is the ratio of the Area (% of total land area) of Lao PDR in 1990 to that in 1992?
Give a very brief answer. 1. What is the ratio of the Area (% of total land area) in Philippines in 1990 to that in 1992?
Provide a short and direct response. 1. What is the ratio of the Area (% of total land area) of Philippines in 1990 to that in 1993?
Give a very brief answer. 1.01. What is the ratio of the Area (% of total land area) in Togo in 1990 to that in 1993?
Give a very brief answer. 0.97. What is the ratio of the Area (% of total land area) in Faeroe Islands in 1991 to that in 1992?
Offer a terse response. 1. What is the ratio of the Area (% of total land area) of Philippines in 1991 to that in 1992?
Make the answer very short. 1. What is the ratio of the Area (% of total land area) of Faeroe Islands in 1991 to that in 1993?
Keep it short and to the point. 1. What is the ratio of the Area (% of total land area) of Lao PDR in 1991 to that in 1993?
Keep it short and to the point. 1. What is the ratio of the Area (% of total land area) of Philippines in 1991 to that in 1993?
Make the answer very short. 1.01. What is the ratio of the Area (% of total land area) of Togo in 1991 to that in 1993?
Keep it short and to the point. 0.97. What is the ratio of the Area (% of total land area) in Philippines in 1992 to that in 1993?
Keep it short and to the point. 1. What is the ratio of the Area (% of total land area) of Togo in 1992 to that in 1993?
Your answer should be very brief. 0.97. What is the difference between the highest and the second highest Area (% of total land area) of Lao PDR?
Your response must be concise. 0. What is the difference between the highest and the second highest Area (% of total land area) in Philippines?
Offer a terse response. 0.06. What is the difference between the highest and the second highest Area (% of total land area) of Togo?
Give a very brief answer. 1.93. What is the difference between the highest and the lowest Area (% of total land area) in Lao PDR?
Provide a short and direct response. 0.12. What is the difference between the highest and the lowest Area (% of total land area) of Philippines?
Keep it short and to the point. 0.59. What is the difference between the highest and the lowest Area (% of total land area) in Togo?
Make the answer very short. 3.86. 